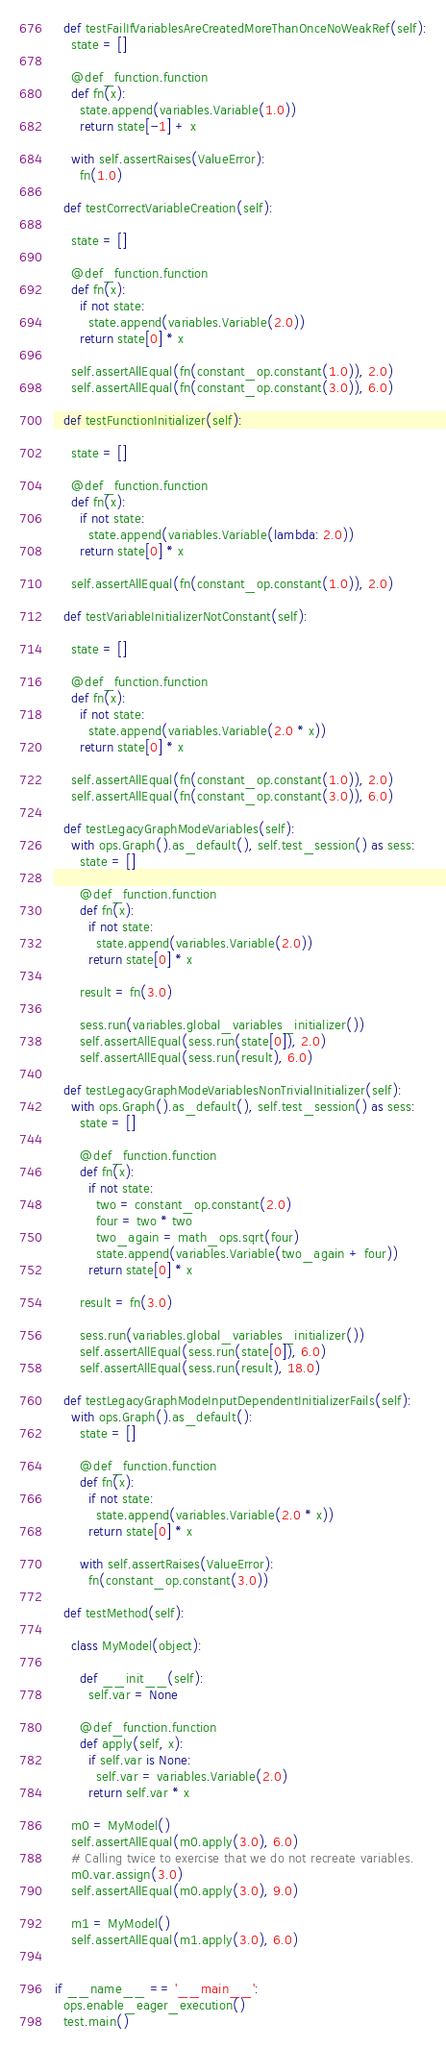<code> <loc_0><loc_0><loc_500><loc_500><_Python_>  def testFailIfVariablesAreCreatedMoreThanOnceNoWeakRef(self):
    state = []

    @def_function.function
    def fn(x):
      state.append(variables.Variable(1.0))
      return state[-1] + x

    with self.assertRaises(ValueError):
      fn(1.0)

  def testCorrectVariableCreation(self):

    state = []

    @def_function.function
    def fn(x):
      if not state:
        state.append(variables.Variable(2.0))
      return state[0] * x

    self.assertAllEqual(fn(constant_op.constant(1.0)), 2.0)
    self.assertAllEqual(fn(constant_op.constant(3.0)), 6.0)

  def testFunctionInitializer(self):

    state = []

    @def_function.function
    def fn(x):
      if not state:
        state.append(variables.Variable(lambda: 2.0))
      return state[0] * x

    self.assertAllEqual(fn(constant_op.constant(1.0)), 2.0)

  def testVariableInitializerNotConstant(self):

    state = []

    @def_function.function
    def fn(x):
      if not state:
        state.append(variables.Variable(2.0 * x))
      return state[0] * x

    self.assertAllEqual(fn(constant_op.constant(1.0)), 2.0)
    self.assertAllEqual(fn(constant_op.constant(3.0)), 6.0)

  def testLegacyGraphModeVariables(self):
    with ops.Graph().as_default(), self.test_session() as sess:
      state = []

      @def_function.function
      def fn(x):
        if not state:
          state.append(variables.Variable(2.0))
        return state[0] * x

      result = fn(3.0)

      sess.run(variables.global_variables_initializer())
      self.assertAllEqual(sess.run(state[0]), 2.0)
      self.assertAllEqual(sess.run(result), 6.0)

  def testLegacyGraphModeVariablesNonTrivialInitializer(self):
    with ops.Graph().as_default(), self.test_session() as sess:
      state = []

      @def_function.function
      def fn(x):
        if not state:
          two = constant_op.constant(2.0)
          four = two * two
          two_again = math_ops.sqrt(four)
          state.append(variables.Variable(two_again + four))
        return state[0] * x

      result = fn(3.0)

      sess.run(variables.global_variables_initializer())
      self.assertAllEqual(sess.run(state[0]), 6.0)
      self.assertAllEqual(sess.run(result), 18.0)

  def testLegacyGraphModeInputDependentInitializerFails(self):
    with ops.Graph().as_default():
      state = []

      @def_function.function
      def fn(x):
        if not state:
          state.append(variables.Variable(2.0 * x))
        return state[0] * x

      with self.assertRaises(ValueError):
        fn(constant_op.constant(3.0))

  def testMethod(self):

    class MyModel(object):

      def __init__(self):
        self.var = None

      @def_function.function
      def apply(self, x):
        if self.var is None:
          self.var = variables.Variable(2.0)
        return self.var * x

    m0 = MyModel()
    self.assertAllEqual(m0.apply(3.0), 6.0)
    # Calling twice to exercise that we do not recreate variables.
    m0.var.assign(3.0)
    self.assertAllEqual(m0.apply(3.0), 9.0)

    m1 = MyModel()
    self.assertAllEqual(m1.apply(3.0), 6.0)


if __name__ == '__main__':
  ops.enable_eager_execution()
  test.main()
</code> 